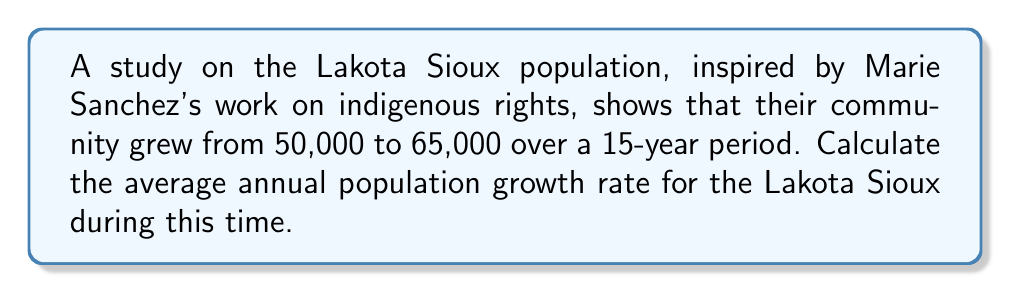Show me your answer to this math problem. To calculate the average annual population growth rate, we'll use the compound annual growth rate (CAGR) formula:

$$ CAGR = \left(\frac{Ending Value}{Beginning Value}\right)^{\frac{1}{n}} - 1 $$

Where:
- Ending Value = 65,000
- Beginning Value = 50,000
- n = 15 years

Step 1: Insert the values into the formula
$$ CAGR = \left(\frac{65,000}{50,000}\right)^{\frac{1}{15}} - 1 $$

Step 2: Simplify the fraction inside the parentheses
$$ CAGR = \left(1.3\right)^{\frac{1}{15}} - 1 $$

Step 3: Calculate the 15th root of 1.3
$$ CAGR = 1.0176 - 1 $$

Step 4: Subtract 1 and convert to a percentage
$$ CAGR = 0.0176 = 1.76\% $$

Therefore, the average annual population growth rate for the Lakota Sioux community during this 15-year period was approximately 1.76%.
Answer: 1.76% 